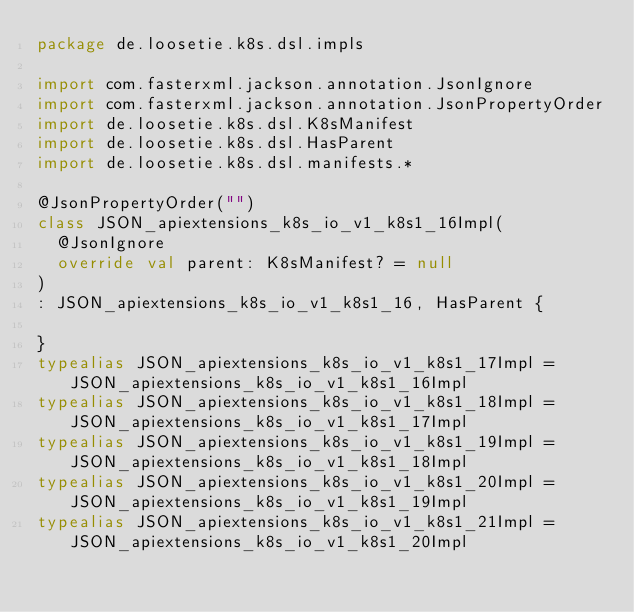Convert code to text. <code><loc_0><loc_0><loc_500><loc_500><_Kotlin_>package de.loosetie.k8s.dsl.impls

import com.fasterxml.jackson.annotation.JsonIgnore
import com.fasterxml.jackson.annotation.JsonPropertyOrder
import de.loosetie.k8s.dsl.K8sManifest
import de.loosetie.k8s.dsl.HasParent
import de.loosetie.k8s.dsl.manifests.*

@JsonPropertyOrder("")
class JSON_apiextensions_k8s_io_v1_k8s1_16Impl(
  @JsonIgnore
  override val parent: K8sManifest? = null
)
: JSON_apiextensions_k8s_io_v1_k8s1_16, HasParent {
  
}
typealias JSON_apiextensions_k8s_io_v1_k8s1_17Impl = JSON_apiextensions_k8s_io_v1_k8s1_16Impl
typealias JSON_apiextensions_k8s_io_v1_k8s1_18Impl = JSON_apiextensions_k8s_io_v1_k8s1_17Impl
typealias JSON_apiextensions_k8s_io_v1_k8s1_19Impl = JSON_apiextensions_k8s_io_v1_k8s1_18Impl
typealias JSON_apiextensions_k8s_io_v1_k8s1_20Impl = JSON_apiextensions_k8s_io_v1_k8s1_19Impl
typealias JSON_apiextensions_k8s_io_v1_k8s1_21Impl = JSON_apiextensions_k8s_io_v1_k8s1_20Impl</code> 